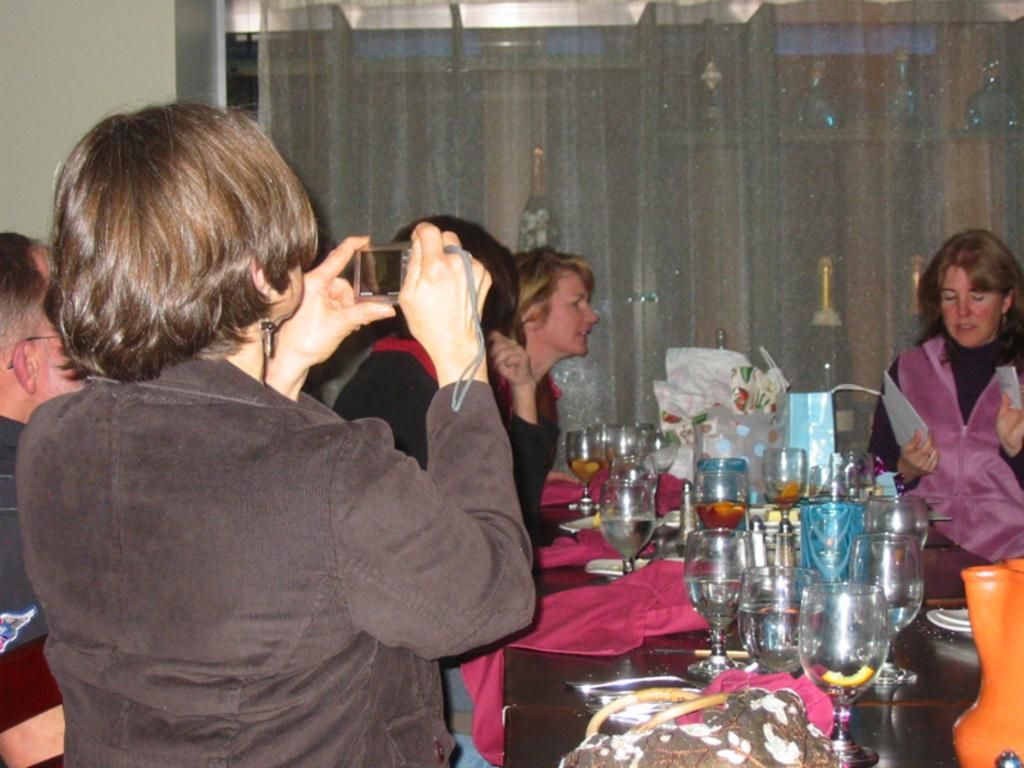Who or what can be seen in the image? There are people in the image. What is on the table in the image? There is a table with glasses in the image, and there are objects on the table. What can be seen in the background of the image? There is a curtain in the background of the image. What is visible at the top of the image? There are lights on the roof at the top of the image. How does the brake work on the table in the image? There is no brake present in the image; it is a table with glasses and other objects. Can you tell me how fast the people are running in the image? There is no indication of running in the image; the people are stationary. 